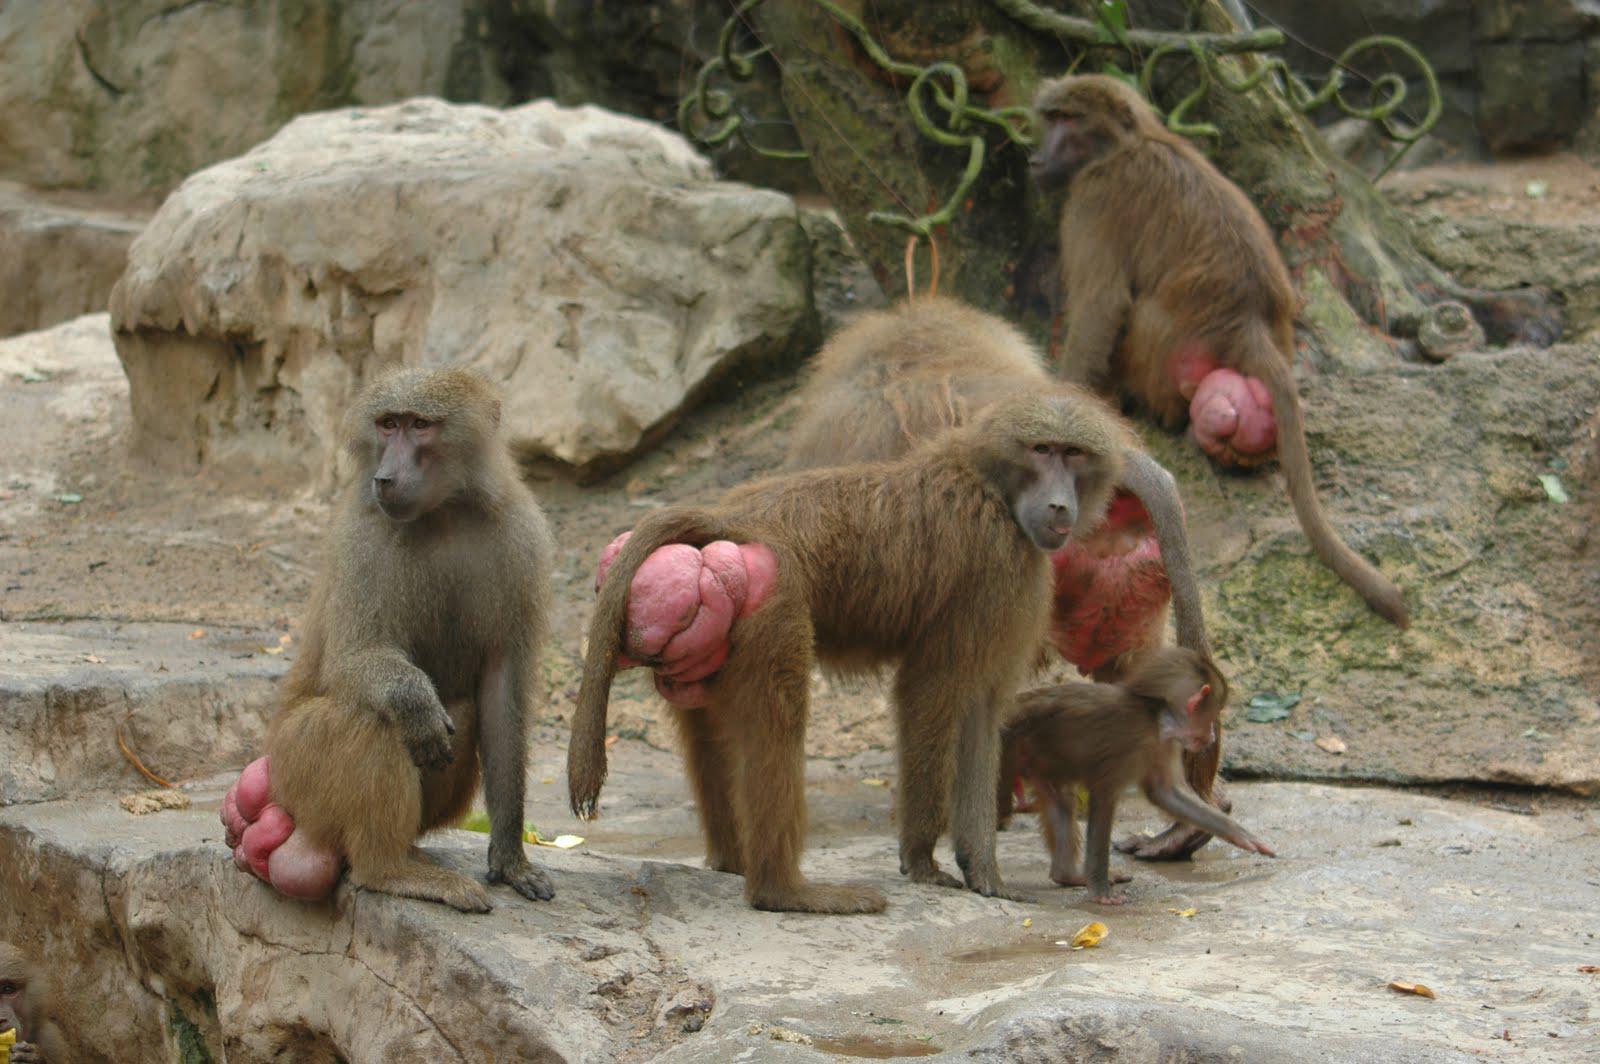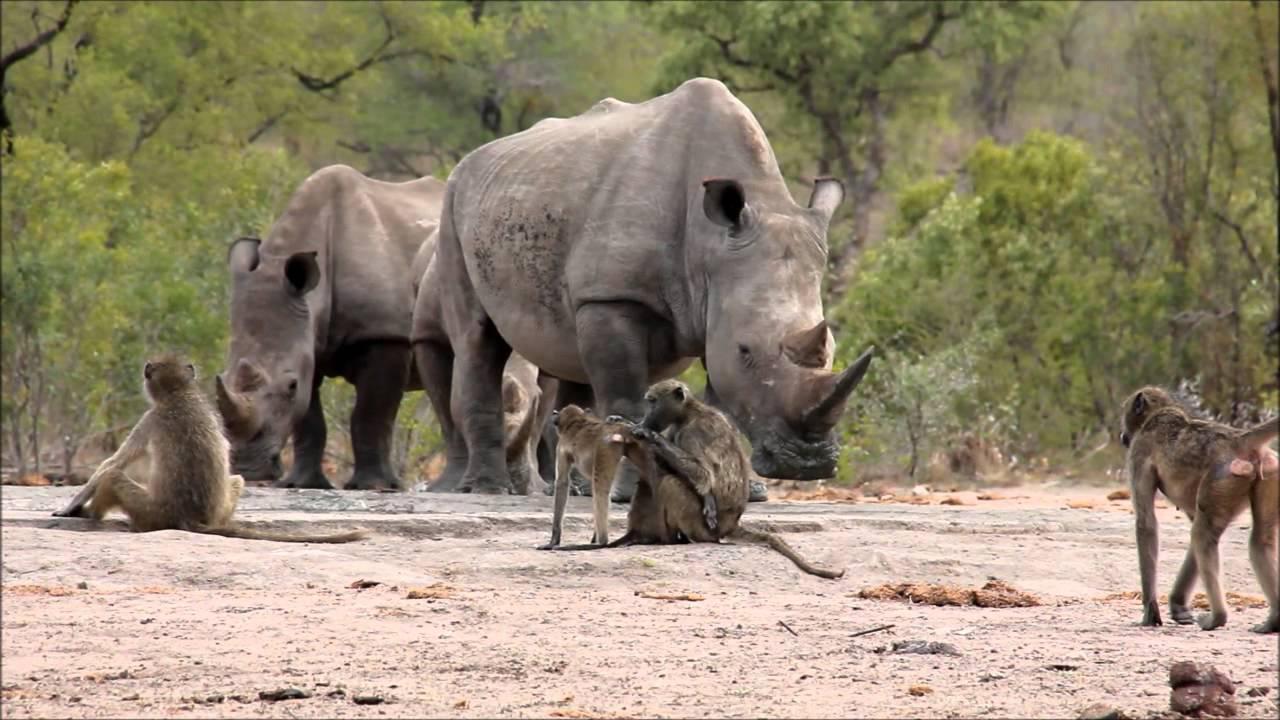The first image is the image on the left, the second image is the image on the right. Examine the images to the left and right. Is the description "There are no more than half a dozen primates in the image on the left." accurate? Answer yes or no. Yes. The first image is the image on the left, the second image is the image on the right. Evaluate the accuracy of this statement regarding the images: "Baboons are mostly walking in one direction, in one image.". Is it true? Answer yes or no. No. 